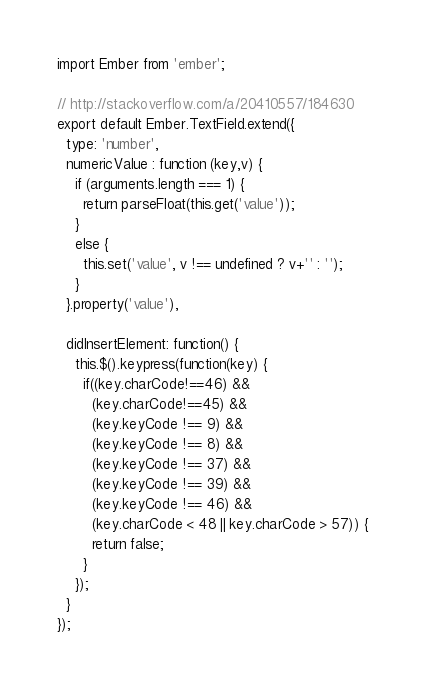<code> <loc_0><loc_0><loc_500><loc_500><_JavaScript_>import Ember from 'ember';

// http://stackoverflow.com/a/20410557/184630
export default Ember.TextField.extend({
  type: 'number',
  numericValue : function (key,v) {
    if (arguments.length === 1) {
      return parseFloat(this.get('value'));
    }
    else {
      this.set('value', v !== undefined ? v+'' : '');
    }
  }.property('value'),

  didInsertElement: function() {
    this.$().keypress(function(key) {
      if((key.charCode!==46) &&
        (key.charCode!==45) &&
        (key.keyCode !== 9) &&
        (key.keyCode !== 8) &&
        (key.keyCode !== 37) &&
        (key.keyCode !== 39) &&
        (key.keyCode !== 46) &&
        (key.charCode < 48 || key.charCode > 57)) {
        return false;
      }
    });
  }
});
</code> 